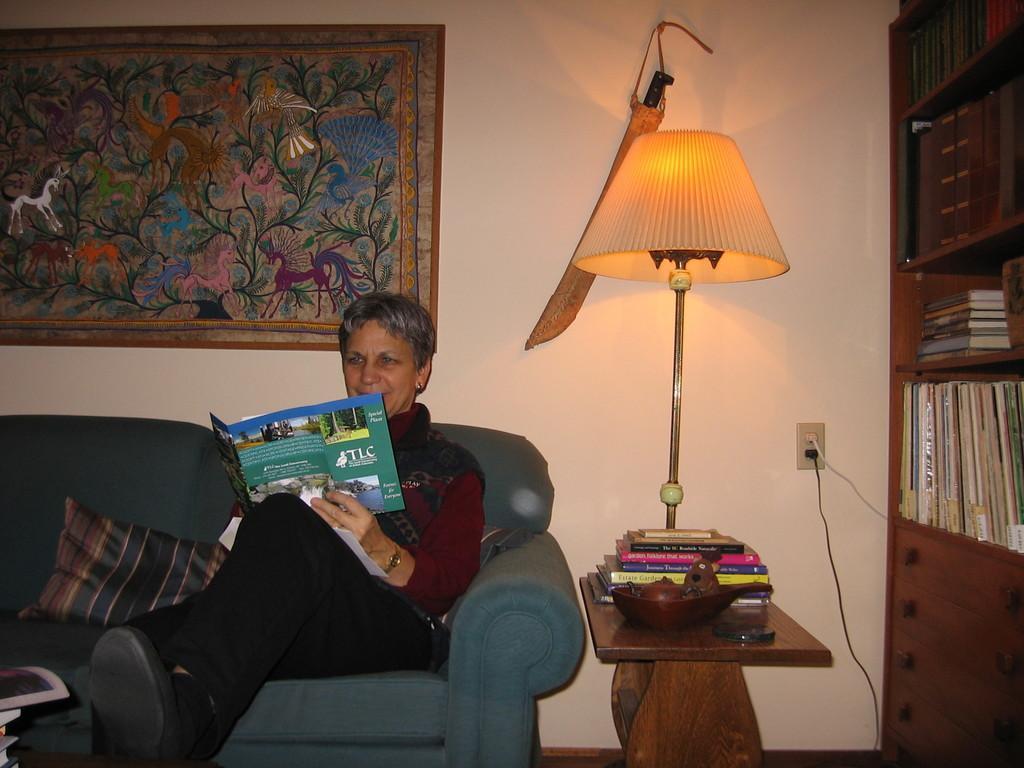Could you give a brief overview of what you see in this image? This picture is taken inside the room where a woman is sitting on the sofa which is in the center. At the right side there is a shelf and books are filled in the shelves. In the background a wall and a frame is attached on the wall. In the center there is a table, on the table there are books, lamp. Woman is holding a book in her hand. On the sofa there is a cushion. 